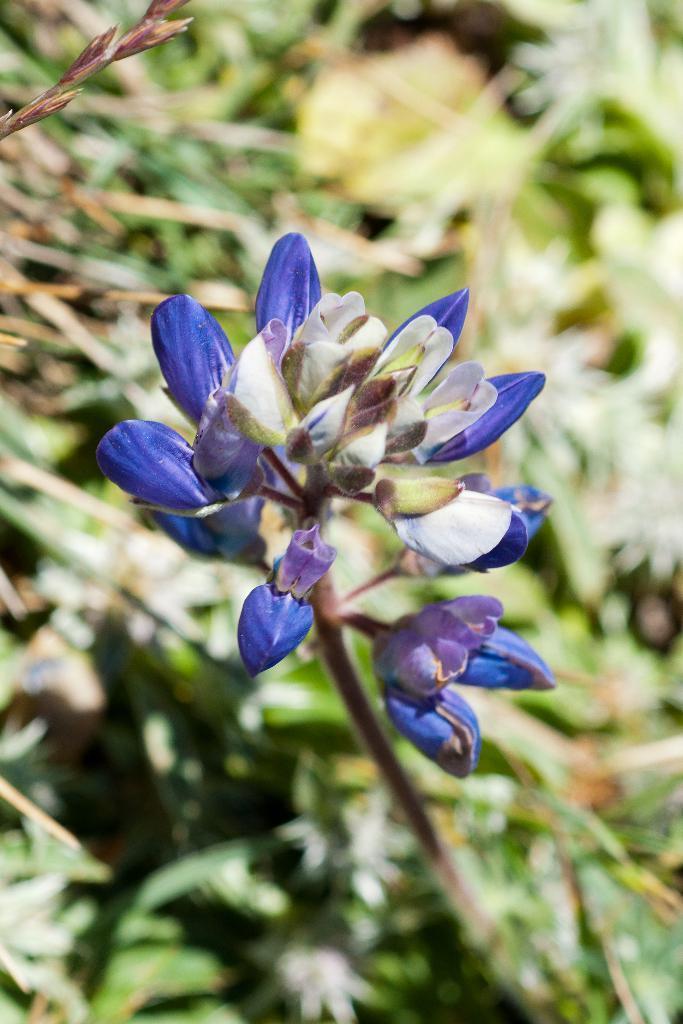In one or two sentences, can you explain what this image depicts? In the foreground of the image we can see purple color flowers and stem. In the background, we can see greenery. 